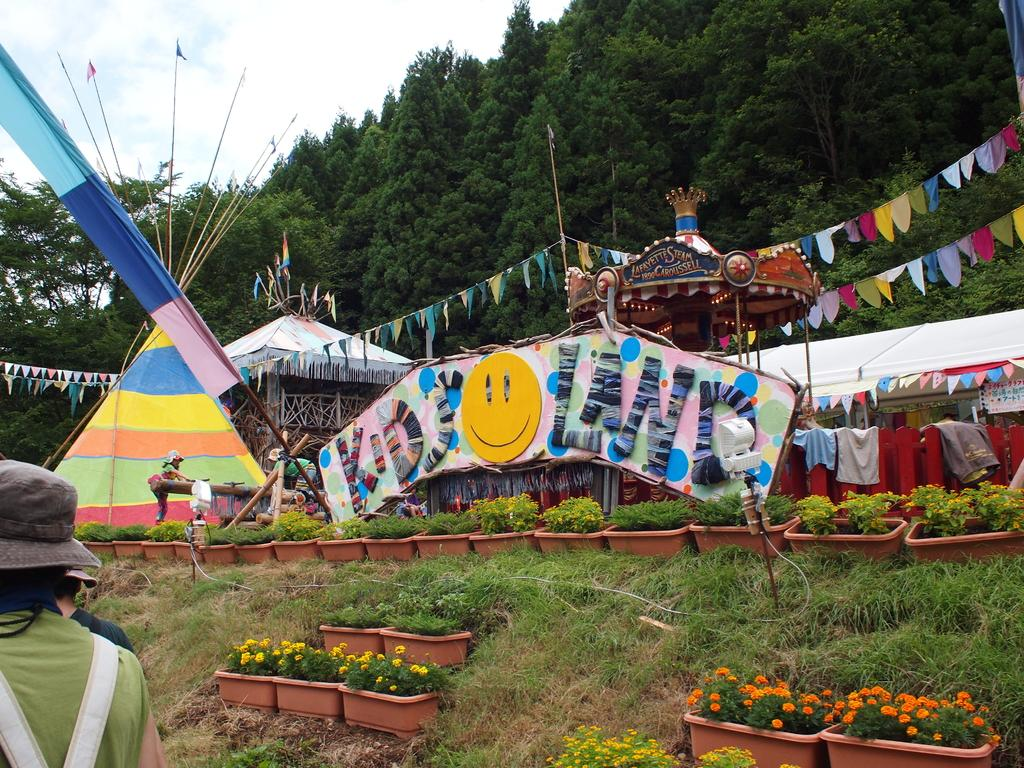What type of vegetation can be seen in the image? There are plants, flowers, and grass visible in the image. What else is present in the image besides vegetation? There are flags, a board, sheds, and two persons in the image. What can be seen in the background of the image? There are trees and the sky visible in the background of the image. What is the cent of interest in the image? There is no mention of a cent or interest in the image; it features plants, flowers, grass, flags, a board, sheds, and two persons. How do the two persons play with the plants in the image? There is no indication that the two persons are playing with the plants in the image. 